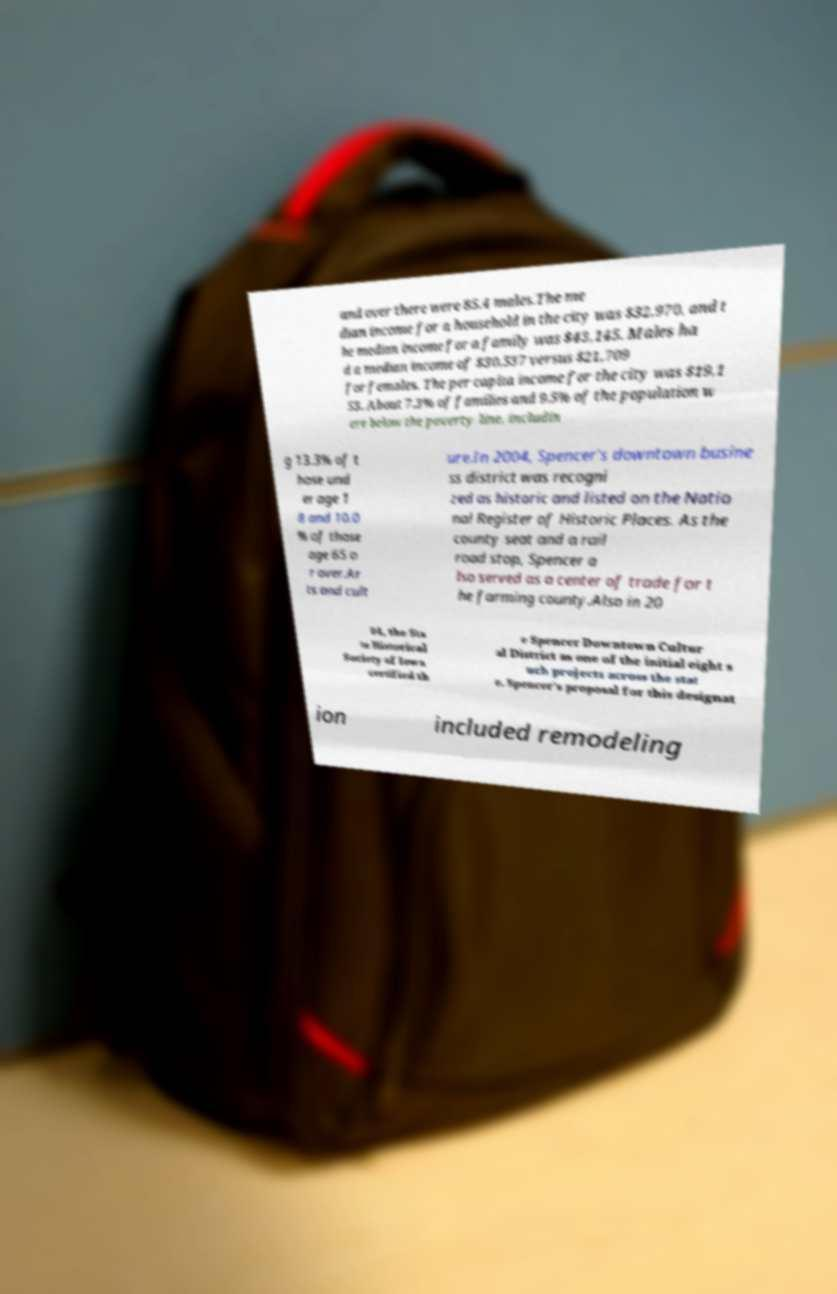I need the written content from this picture converted into text. Can you do that? and over there were 85.4 males.The me dian income for a household in the city was $32,970, and t he median income for a family was $43,145. Males ha d a median income of $30,537 versus $21,709 for females. The per capita income for the city was $19,1 53. About 7.3% of families and 9.5% of the population w ere below the poverty line, includin g 13.3% of t hose und er age 1 8 and 10.0 % of those age 65 o r over.Ar ts and cult ure.In 2004, Spencer's downtown busine ss district was recogni zed as historic and listed on the Natio nal Register of Historic Places. As the county seat and a rail road stop, Spencer a lso served as a center of trade for t he farming county.Also in 20 04, the Sta te Historical Society of Iowa certified th e Spencer Downtown Cultur al District as one of the initial eight s uch projects across the stat e. Spencer's proposal for this designat ion included remodeling 